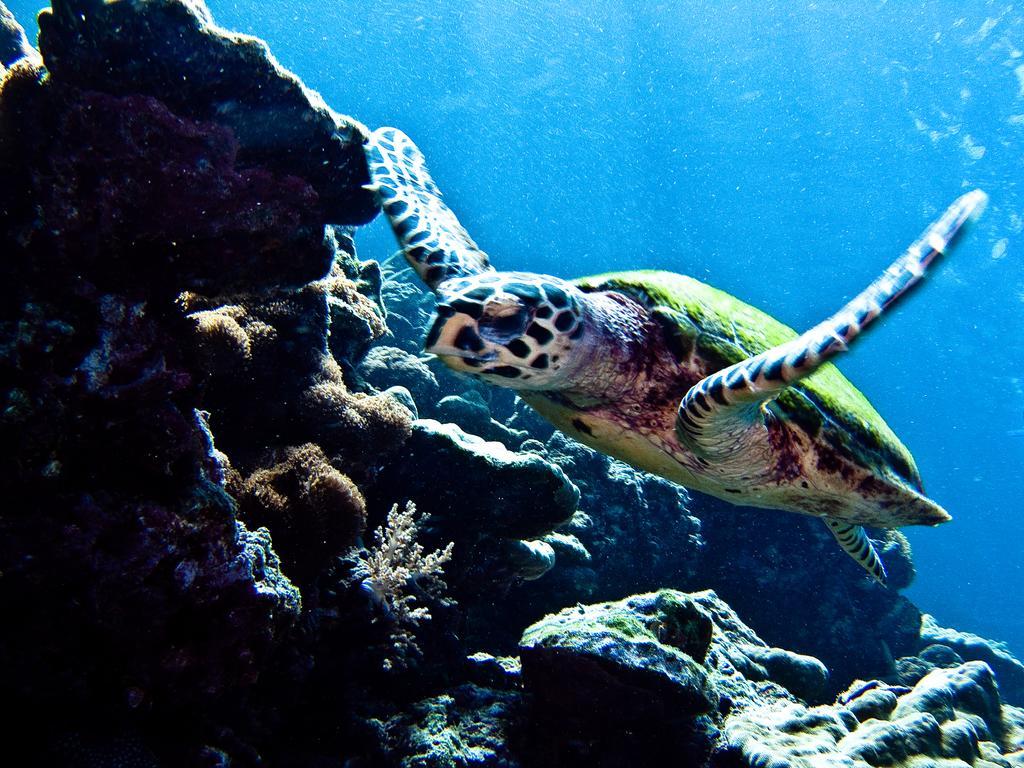Can you describe this image briefly? In this image I can see a turtle swimming in the water. There are rocks and plants at the back. 